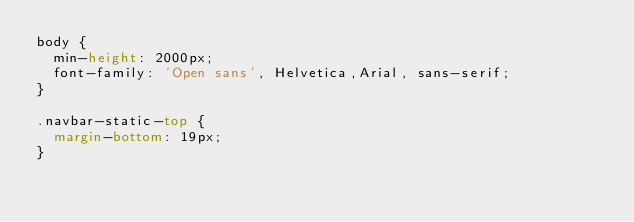<code> <loc_0><loc_0><loc_500><loc_500><_CSS_>body {
  min-height: 2000px;
  font-family: 'Open sans', Helvetica,Arial, sans-serif;
}

.navbar-static-top {
  margin-bottom: 19px;
}
</code> 